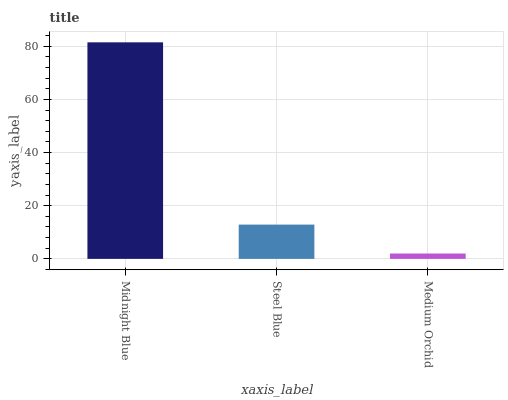Is Medium Orchid the minimum?
Answer yes or no. Yes. Is Midnight Blue the maximum?
Answer yes or no. Yes. Is Steel Blue the minimum?
Answer yes or no. No. Is Steel Blue the maximum?
Answer yes or no. No. Is Midnight Blue greater than Steel Blue?
Answer yes or no. Yes. Is Steel Blue less than Midnight Blue?
Answer yes or no. Yes. Is Steel Blue greater than Midnight Blue?
Answer yes or no. No. Is Midnight Blue less than Steel Blue?
Answer yes or no. No. Is Steel Blue the high median?
Answer yes or no. Yes. Is Steel Blue the low median?
Answer yes or no. Yes. Is Medium Orchid the high median?
Answer yes or no. No. Is Midnight Blue the low median?
Answer yes or no. No. 